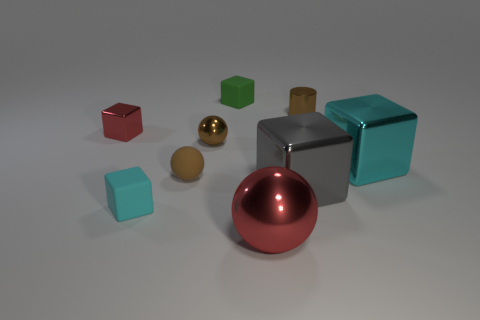Subtract all green blocks. How many blocks are left? 4 Subtract all tiny cyan matte cubes. How many cubes are left? 4 Subtract all green cubes. Subtract all green cylinders. How many cubes are left? 4 Add 1 large red cylinders. How many objects exist? 10 Subtract all blocks. How many objects are left? 4 Subtract 1 green blocks. How many objects are left? 8 Subtract all small brown metallic spheres. Subtract all metallic things. How many objects are left? 2 Add 6 red shiny things. How many red shiny things are left? 8 Add 2 large spheres. How many large spheres exist? 3 